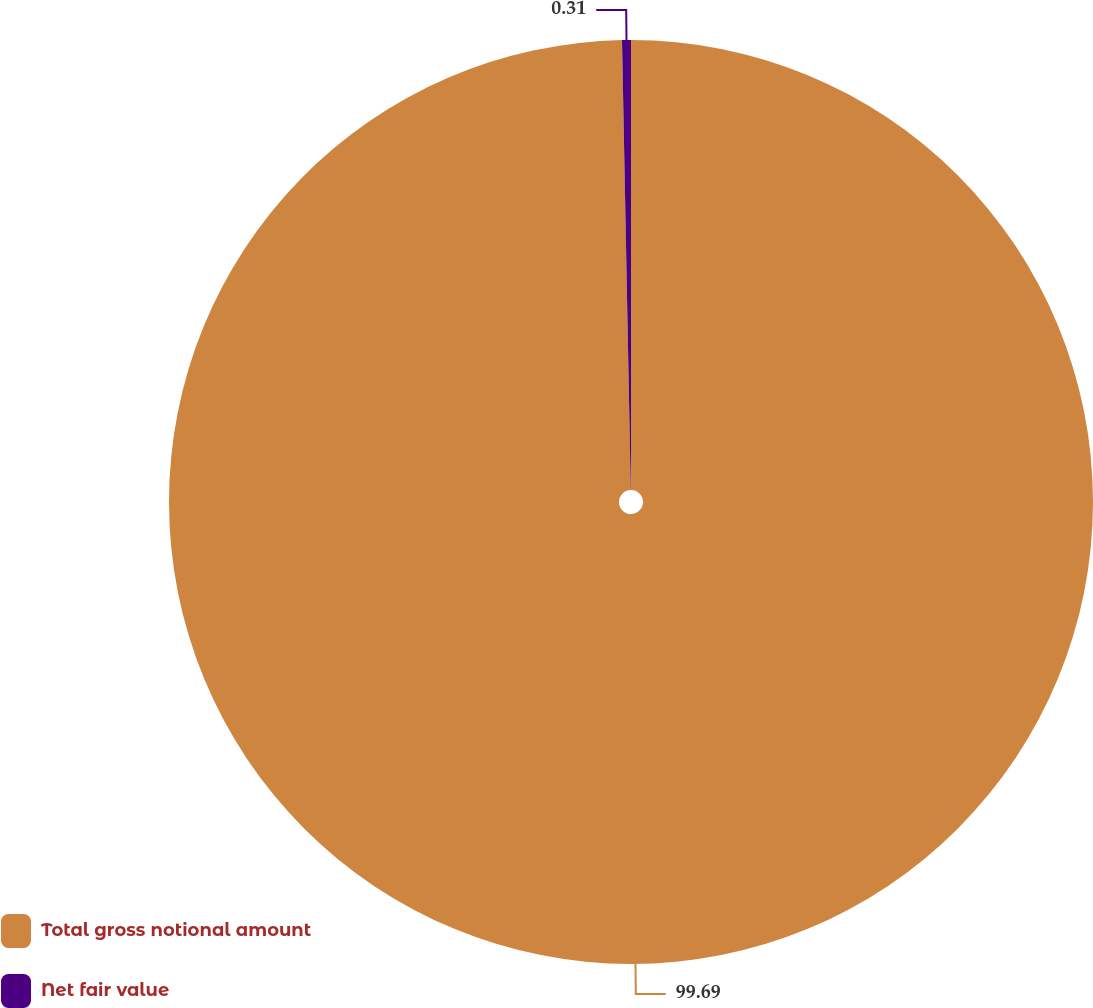Convert chart to OTSL. <chart><loc_0><loc_0><loc_500><loc_500><pie_chart><fcel>Total gross notional amount<fcel>Net fair value<nl><fcel>99.69%<fcel>0.31%<nl></chart> 